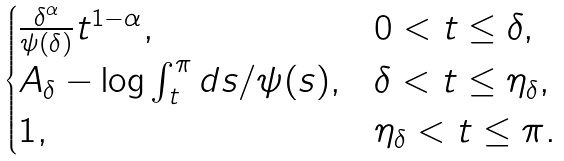<formula> <loc_0><loc_0><loc_500><loc_500>\begin{cases} \frac { \delta ^ { \alpha } } { \psi ( \delta ) } t ^ { 1 - \alpha } , & 0 < t \leq \delta , \\ A _ { \delta } - \log \int _ { t } ^ { \pi } d s / \psi ( s ) , & \delta < t \leq \eta _ { \delta } , \\ 1 , & \eta _ { \delta } < t \leq \pi . \end{cases}</formula> 